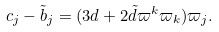Convert formula to latex. <formula><loc_0><loc_0><loc_500><loc_500>c _ { j } - \tilde { b } _ { j } = ( 3 d + 2 \tilde { d } \varpi ^ { k } \varpi _ { k } ) \varpi _ { j } .</formula> 